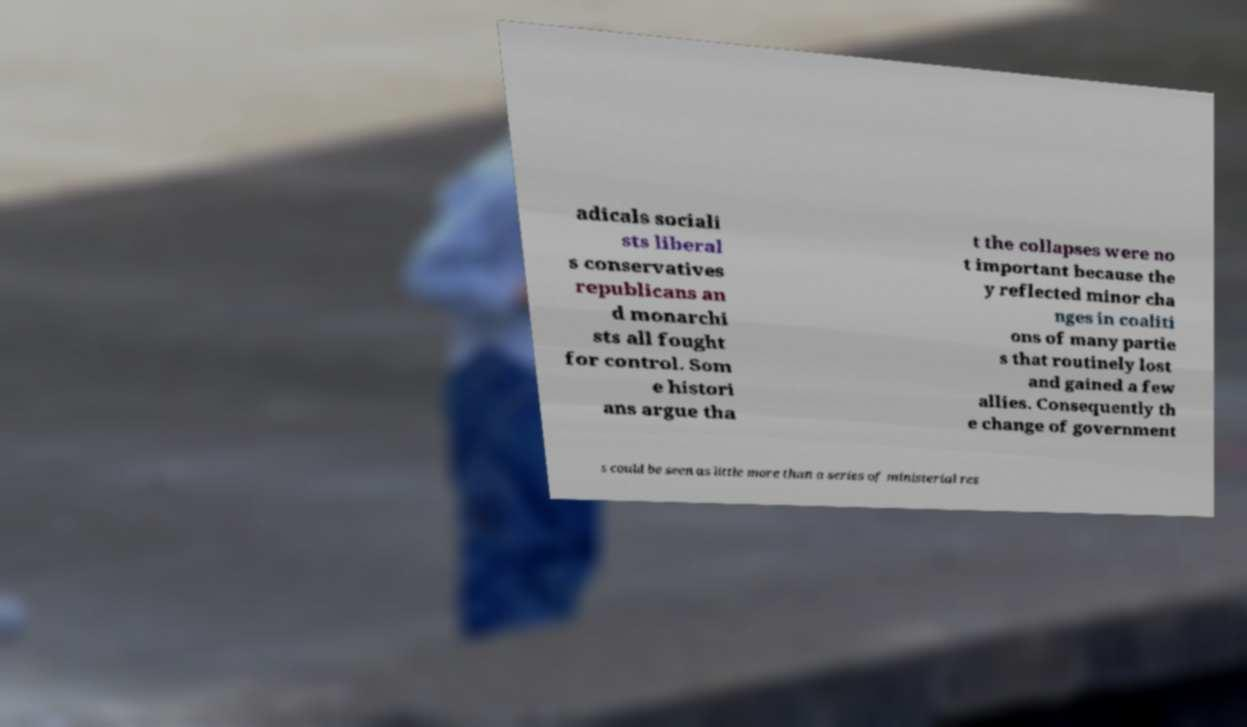Could you extract and type out the text from this image? adicals sociali sts liberal s conservatives republicans an d monarchi sts all fought for control. Som e histori ans argue tha t the collapses were no t important because the y reflected minor cha nges in coaliti ons of many partie s that routinely lost and gained a few allies. Consequently th e change of government s could be seen as little more than a series of ministerial res 